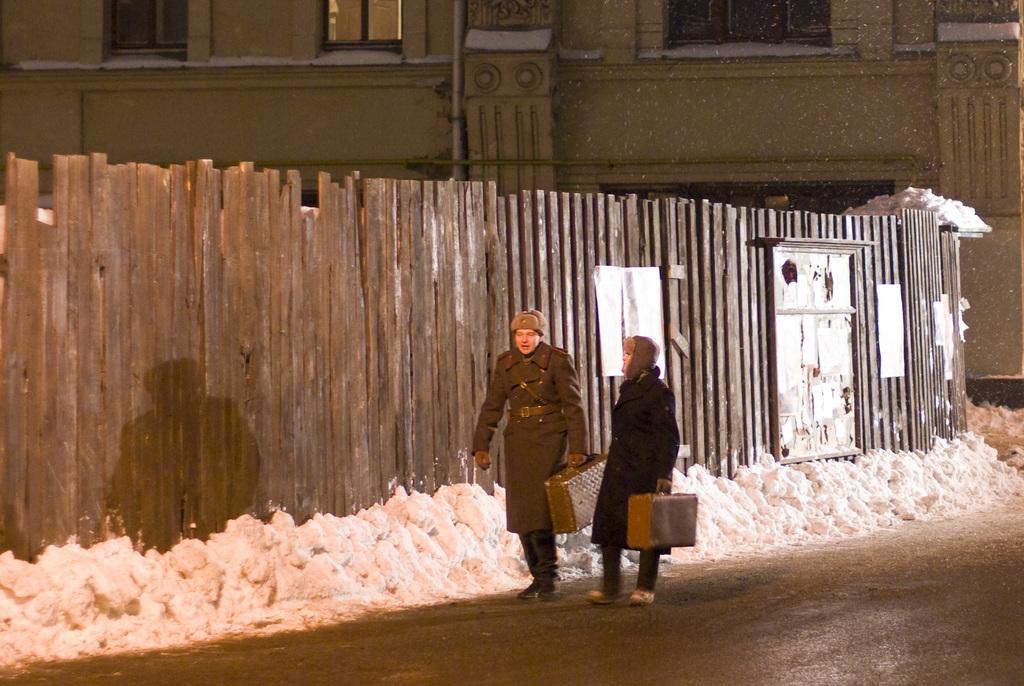In one or two sentences, can you explain what this image depicts? In this picture we can see two persons walking here, they are carrying suitcases, we can see snow here, on the left side there are some sheets, in the background there is a building , we can see a window here. 